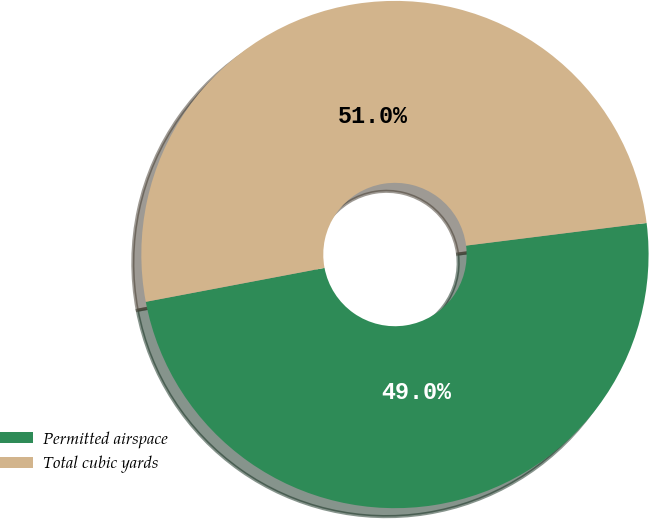Convert chart. <chart><loc_0><loc_0><loc_500><loc_500><pie_chart><fcel>Permitted airspace<fcel>Total cubic yards<nl><fcel>49.0%<fcel>51.0%<nl></chart> 